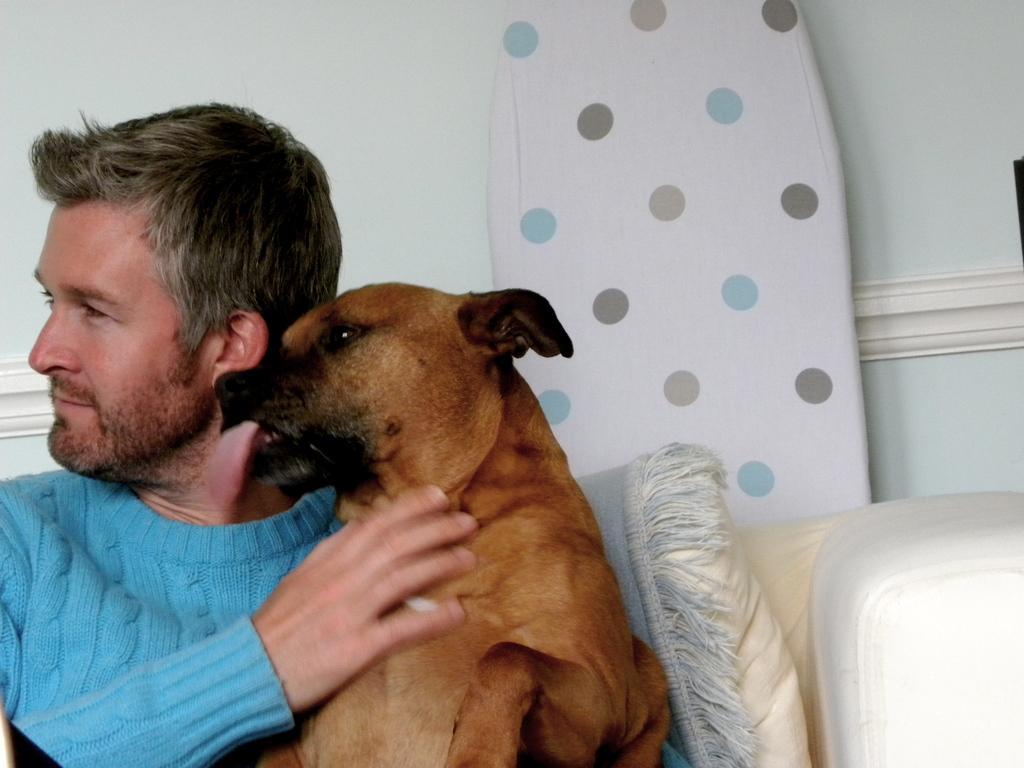Could you give a brief overview of what you see in this image? This person sitting on the chair and holding dog with his hands. On the background we can see wall. 